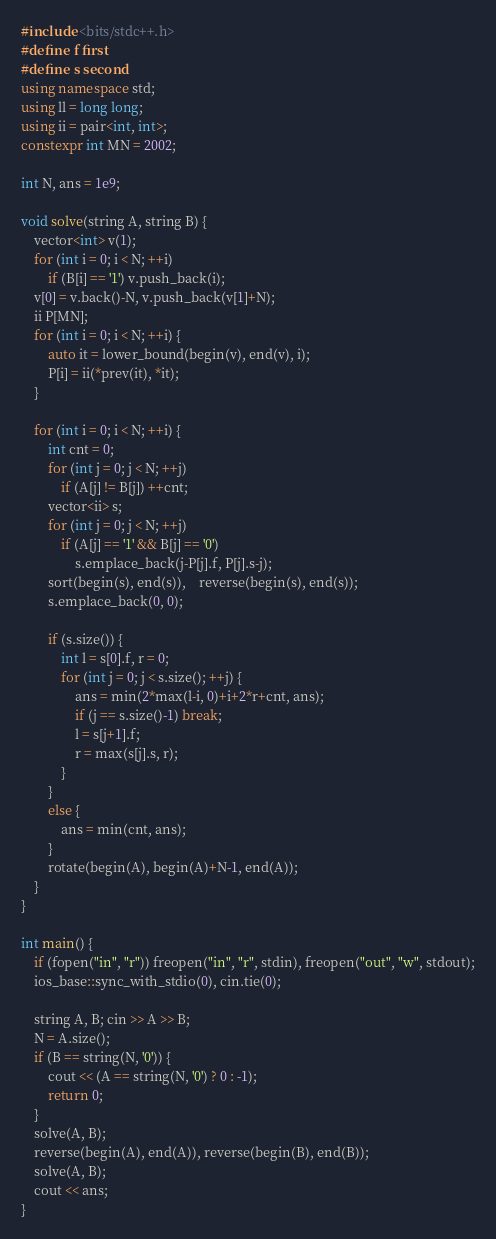<code> <loc_0><loc_0><loc_500><loc_500><_C++_>#include <bits/stdc++.h>
#define f first
#define s second
using namespace std;
using ll = long long;
using ii = pair<int, int>;
constexpr int MN = 2002;

int N, ans = 1e9;

void solve(string A, string B) {
	vector<int> v(1);
	for (int i = 0; i < N; ++i)
		if (B[i] == '1') v.push_back(i);
	v[0] = v.back()-N, v.push_back(v[1]+N);
	ii P[MN];
	for (int i = 0; i < N; ++i) {
		auto it = lower_bound(begin(v), end(v), i);
		P[i] = ii(*prev(it), *it);
	}

	for (int i = 0; i < N; ++i) {
		int cnt = 0;
		for (int j = 0; j < N; ++j)
			if (A[j] != B[j]) ++cnt;
		vector<ii> s;
		for (int j = 0; j < N; ++j)
			if (A[j] == '1' && B[j] == '0')
				s.emplace_back(j-P[j].f, P[j].s-j);
		sort(begin(s), end(s)),	reverse(begin(s), end(s));
		s.emplace_back(0, 0);

		if (s.size()) {
			int l = s[0].f, r = 0;
			for (int j = 0; j < s.size(); ++j) {
				ans = min(2*max(l-i, 0)+i+2*r+cnt, ans);
				if (j == s.size()-1) break;
				l = s[j+1].f;
				r = max(s[j].s, r);
			}
		}
		else {
			ans = min(cnt, ans);
		}
		rotate(begin(A), begin(A)+N-1, end(A));
	}
}

int main() {
	if (fopen("in", "r")) freopen("in", "r", stdin), freopen("out", "w", stdout);
	ios_base::sync_with_stdio(0), cin.tie(0);

	string A, B; cin >> A >> B;
	N = A.size();
	if (B == string(N, '0')) {
		cout << (A == string(N, '0') ? 0 : -1);
		return 0;
	}
	solve(A, B);
	reverse(begin(A), end(A)), reverse(begin(B), end(B));
	solve(A, B);
	cout << ans;
}
</code> 